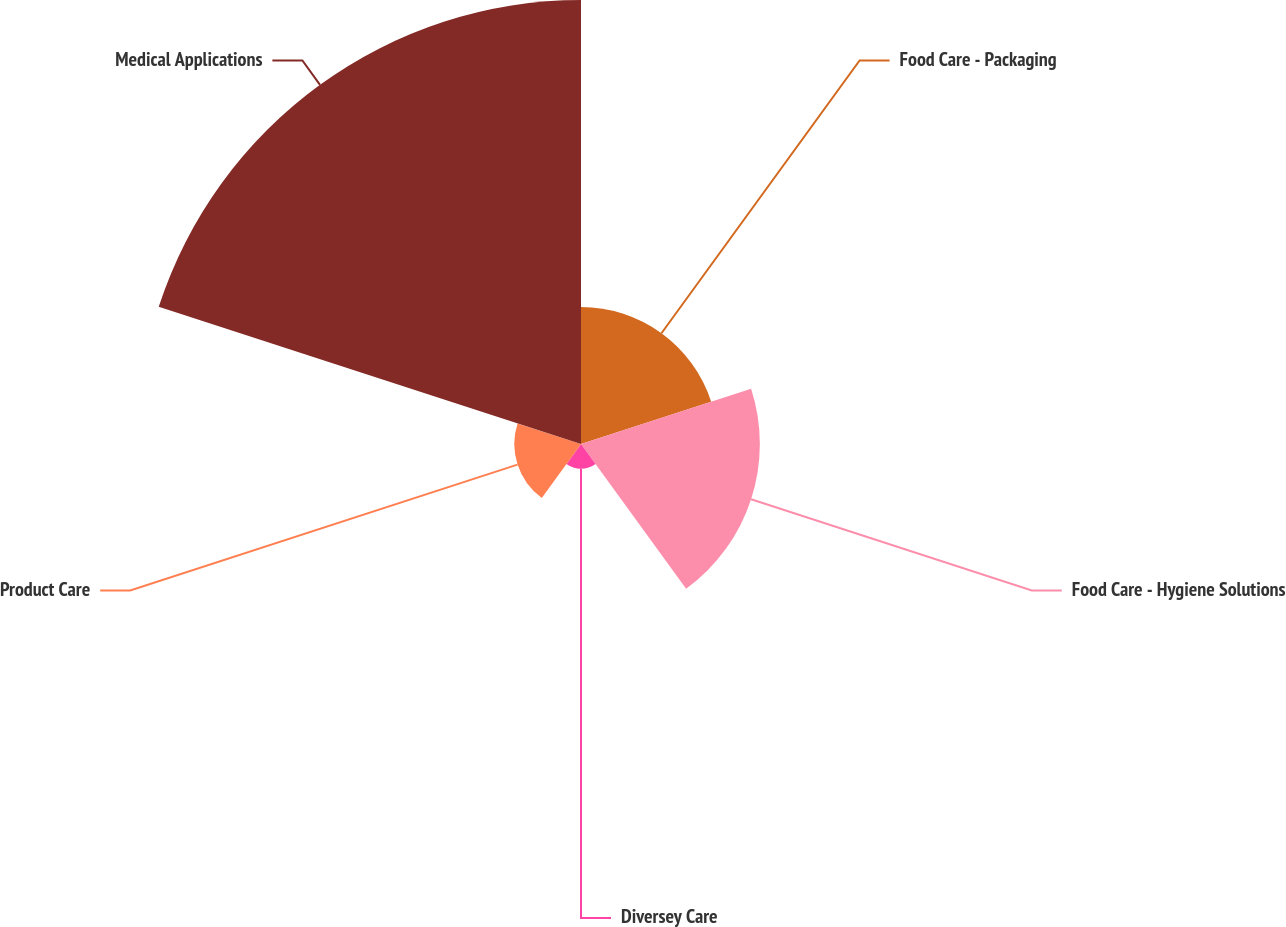<chart> <loc_0><loc_0><loc_500><loc_500><pie_chart><fcel>Food Care - Packaging<fcel>Food Care - Hygiene Solutions<fcel>Diversey Care<fcel>Product Care<fcel>Medical Applications<nl><fcel>16.08%<fcel>21.01%<fcel>2.91%<fcel>7.84%<fcel>52.16%<nl></chart> 